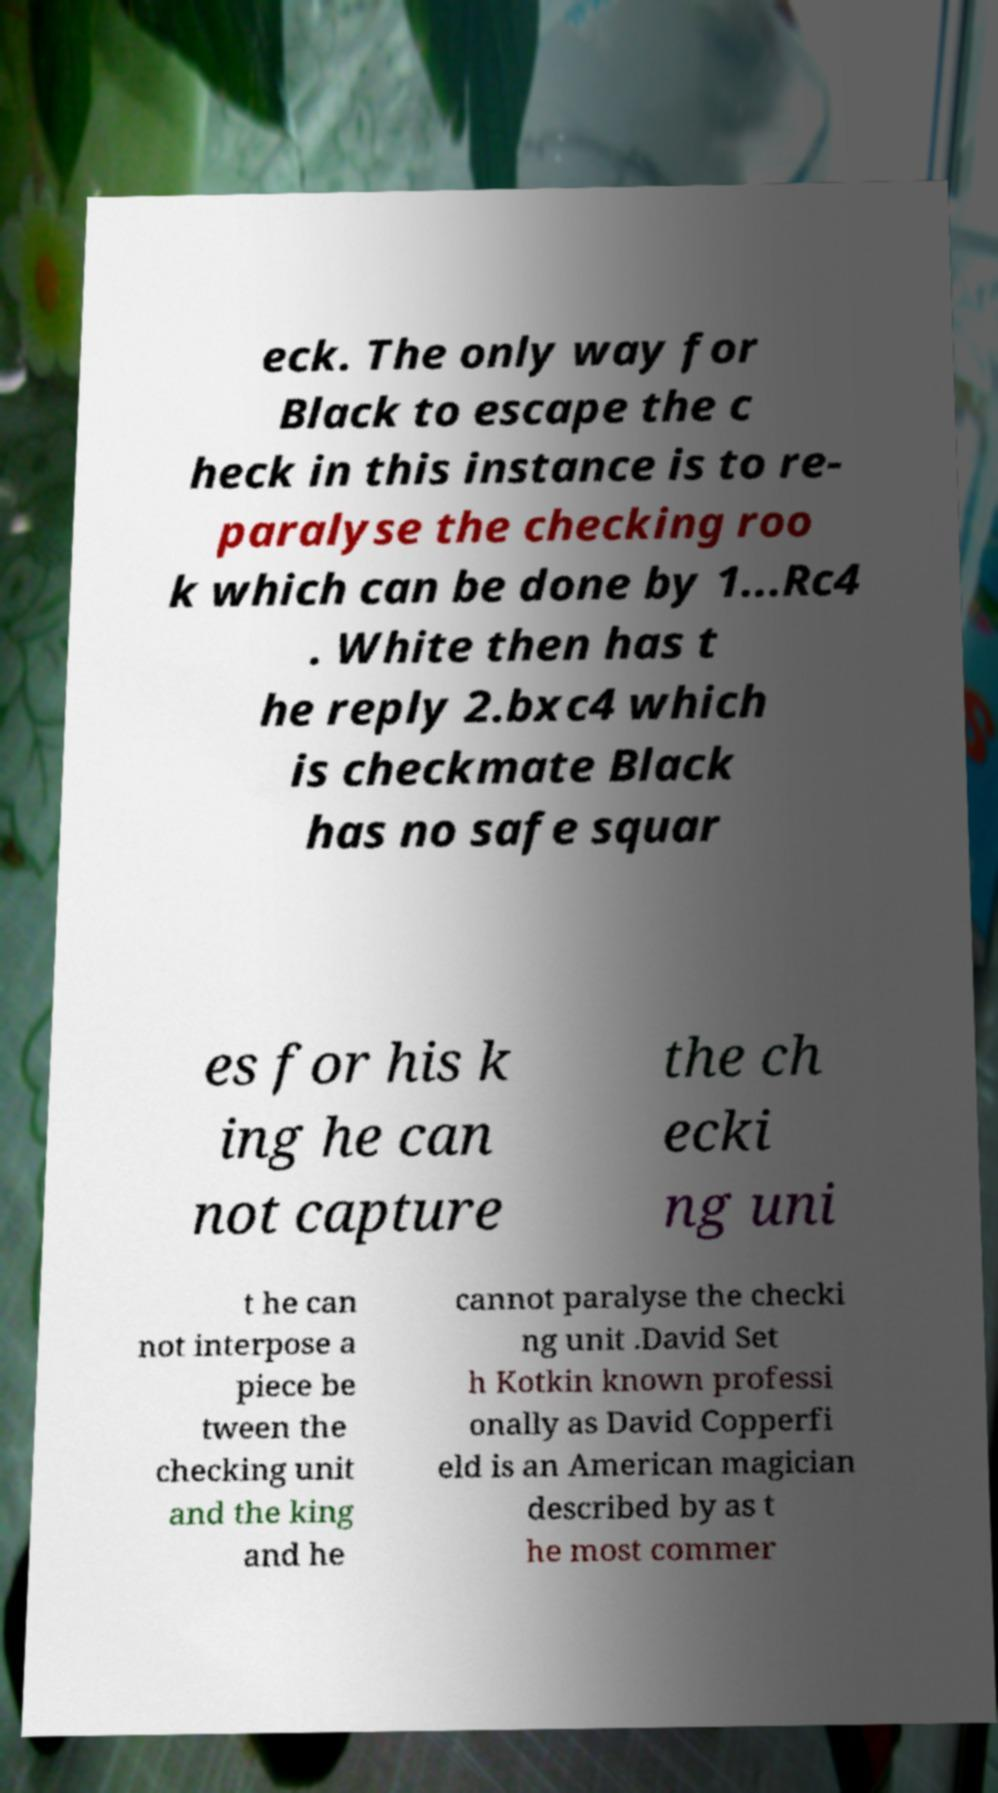Please identify and transcribe the text found in this image. eck. The only way for Black to escape the c heck in this instance is to re- paralyse the checking roo k which can be done by 1...Rc4 . White then has t he reply 2.bxc4 which is checkmate Black has no safe squar es for his k ing he can not capture the ch ecki ng uni t he can not interpose a piece be tween the checking unit and the king and he cannot paralyse the checki ng unit .David Set h Kotkin known professi onally as David Copperfi eld is an American magician described by as t he most commer 